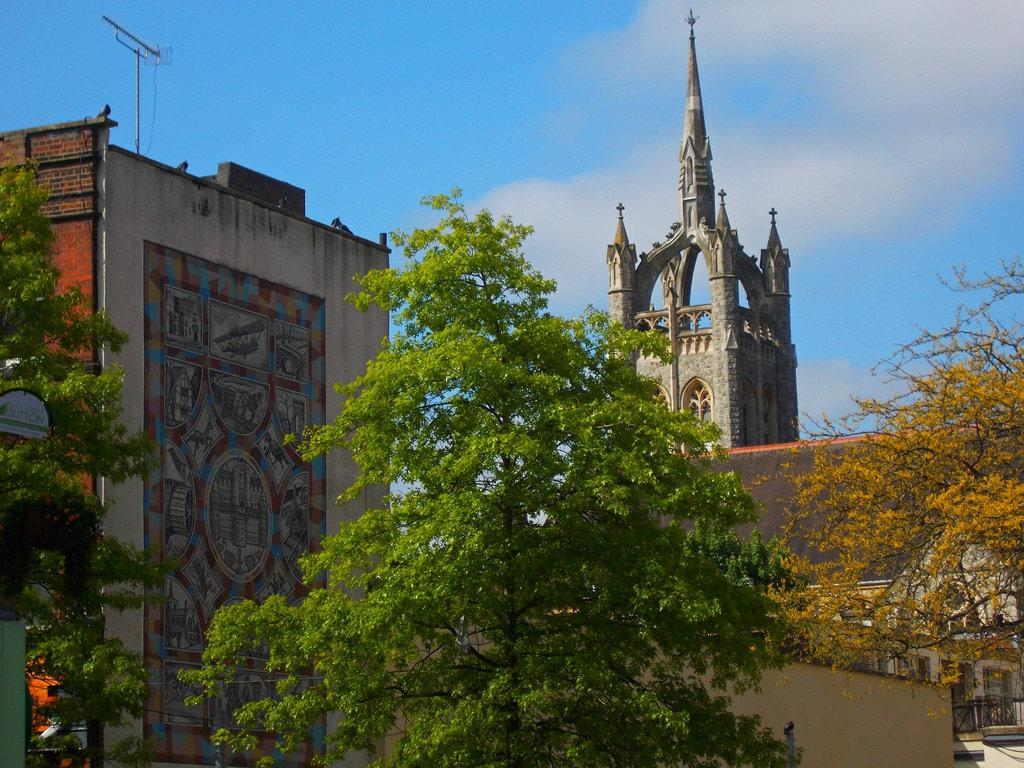What is the main structure in the middle of the image? There is a tower in the middle of the image. What type of vegetation is in front of the tower? There are trees in front of the tower. What is visible at the top of the image? The sky is visible at the top of the image. What other building can be seen in the image? There is a building on the left side of the image. Where is the shop located in the image? There is no shop present in the image. What type of boundary can be seen between the tower and the trees? There is no boundary mentioned or visible between the tower and the trees in the image. 